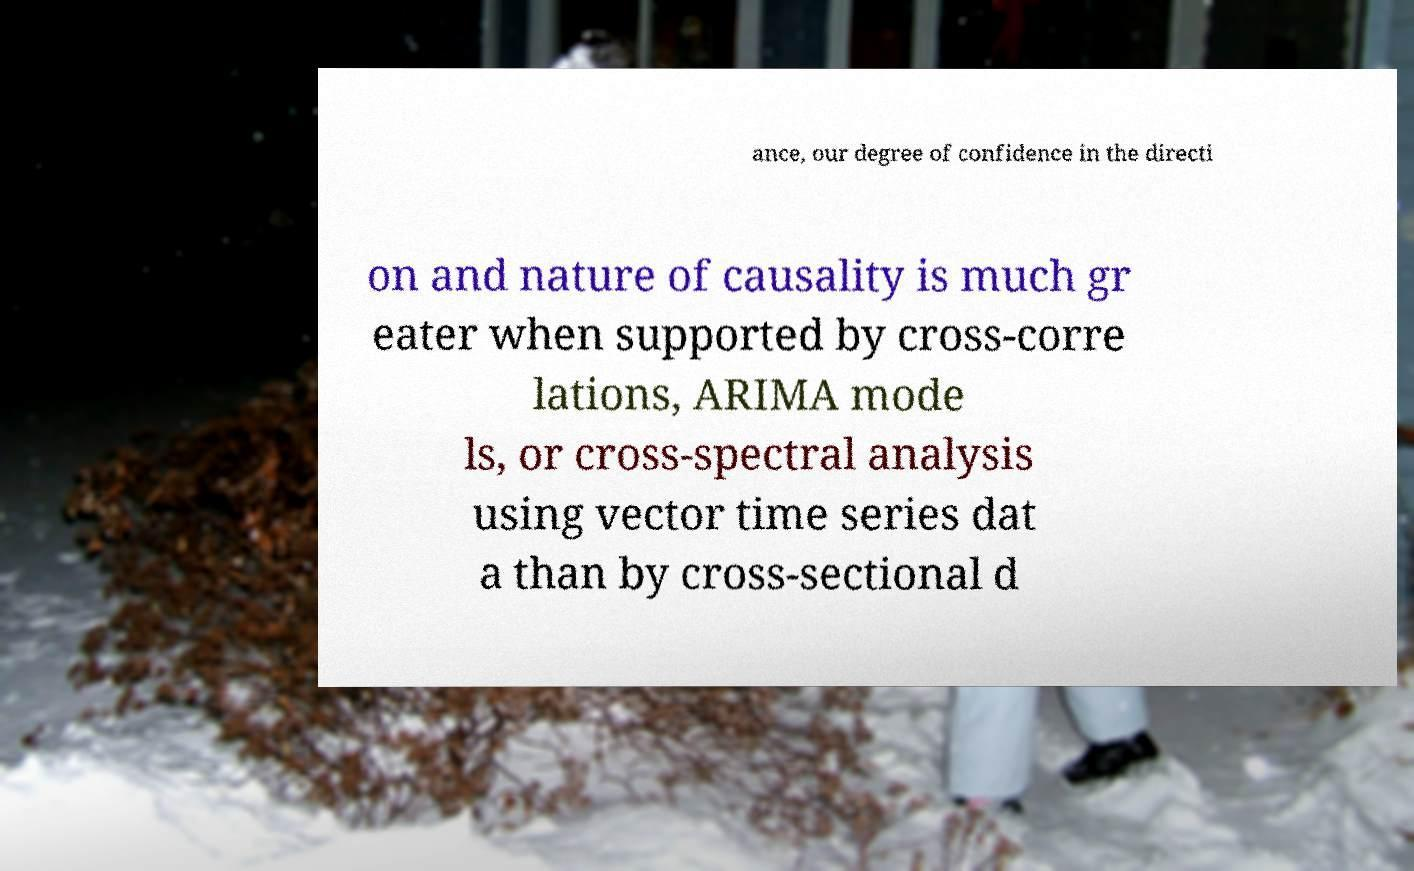Can you read and provide the text displayed in the image?This photo seems to have some interesting text. Can you extract and type it out for me? ance, our degree of confidence in the directi on and nature of causality is much gr eater when supported by cross-corre lations, ARIMA mode ls, or cross-spectral analysis using vector time series dat a than by cross-sectional d 